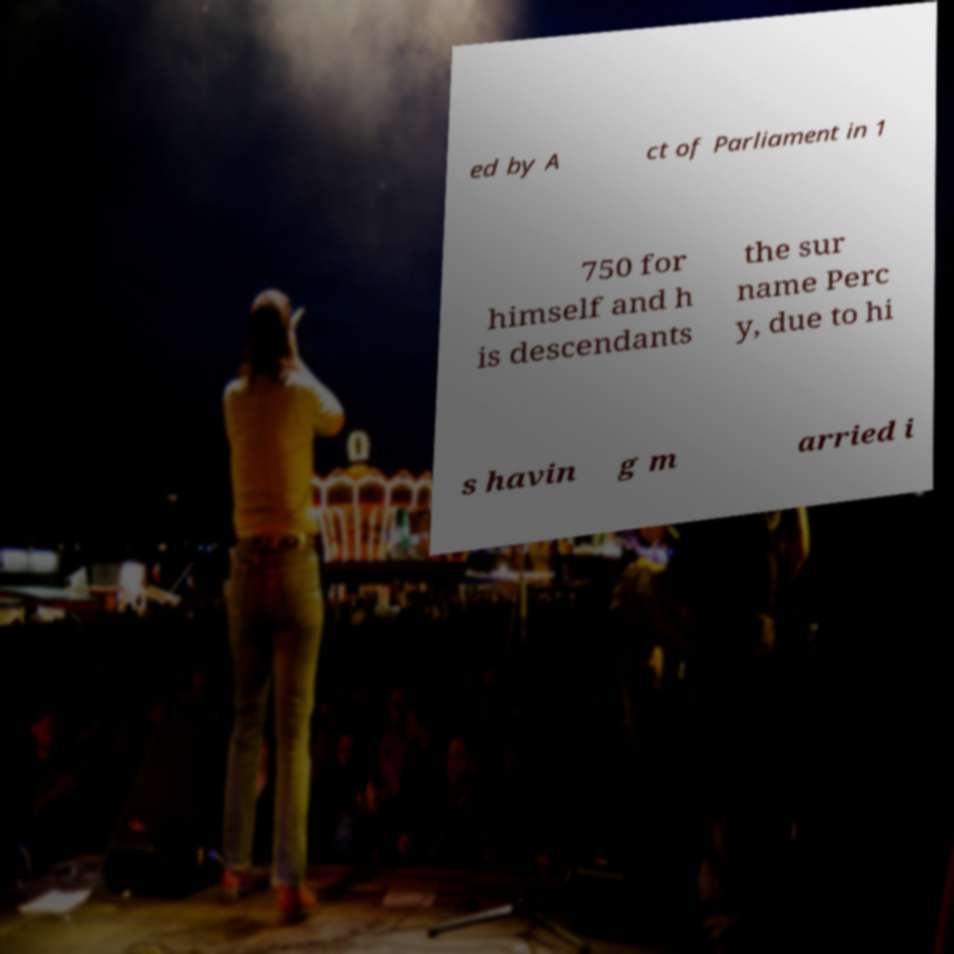For documentation purposes, I need the text within this image transcribed. Could you provide that? ed by A ct of Parliament in 1 750 for himself and h is descendants the sur name Perc y, due to hi s havin g m arried i 